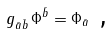<formula> <loc_0><loc_0><loc_500><loc_500>g _ { \bar { a } \bar { b } } \, \Phi ^ { \bar { b } } = \Phi _ { \bar { a } } \text { ,}</formula> 